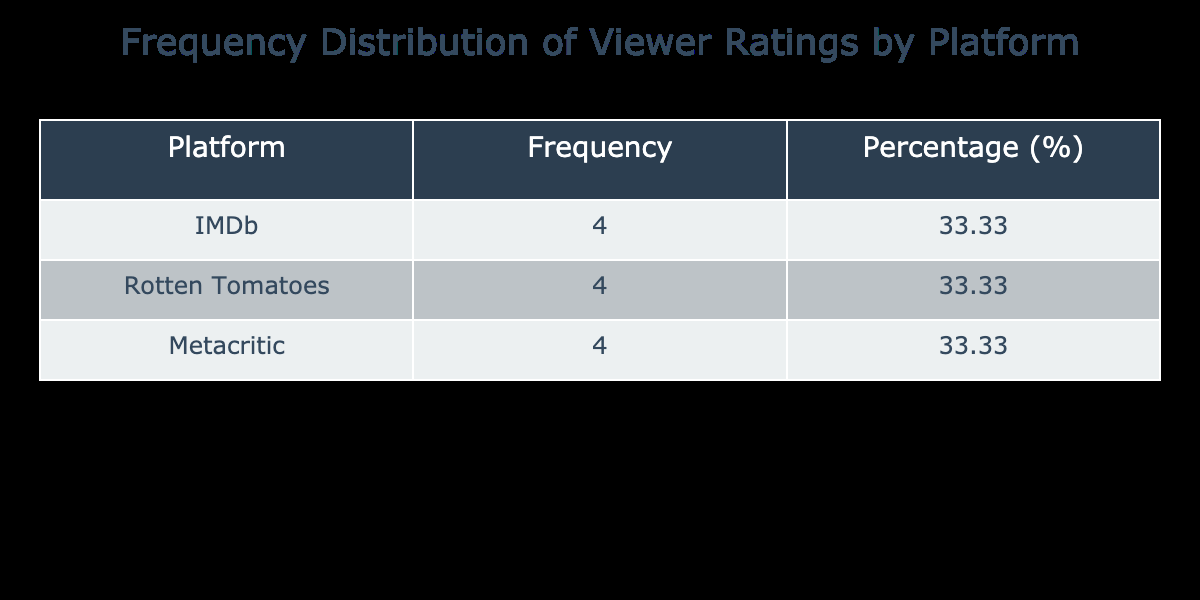What is the frequency of films directed by you on Rotten Tomatoes? The table shows that there are 4 films listed under the Rotten Tomatoes platform, as indicated by the frequency column.
Answer: 4 What percentage of films were rated on IMDb? The table indicates there are 4 films on IMDb out of a total of 12 films. To find the percentage, divide 4 by 12 and then multiply by 100, yielding approximately 33.33%.
Answer: 33.33% Is the number of films directed by you higher on Metacritic than on IMDb? According to the frequency values in the table, both platforms have 4 films each, thus the statement is false.
Answer: No What is the total frequency of films directed by you across all platforms? Adding the frequencies for all platforms from the table yields a total of 12 films (4 on IMDb, 4 on Rotten Tomatoes, and 4 on Metacritic).
Answer: 12 What platform has the highest average viewer rating based on the data provided? First, we compute the average ratings for each platform: IMDb has ratings of 7.8, 8.1, 6.9, and 7.5 (average ≈ 7.53), Rotten Tomatoes has ratings of 85, 90, 92, and 88 (average = 88.75), and Metacritic has ratings of 73, 76, 68, and 70 (average ≈ 71.75). Since 88.75 is the highest average, Rotten Tomatoes has the highest average rating.
Answer: Rotten Tomatoes What is the difference in the number of films directed by you between Rotten Tomatoes and Metacritic? The frequency for Rotten Tomatoes is 4, while for Metacritic, it is also 4. The difference is calculated by subtracting the two values, which results in 0.
Answer: 0 